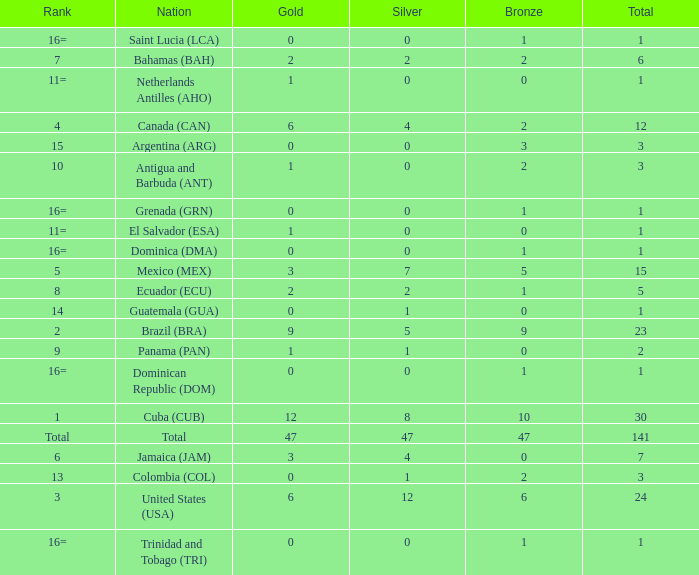How many bronzes have a Nation of jamaica (jam), and a Total smaller than 7? 0.0. 